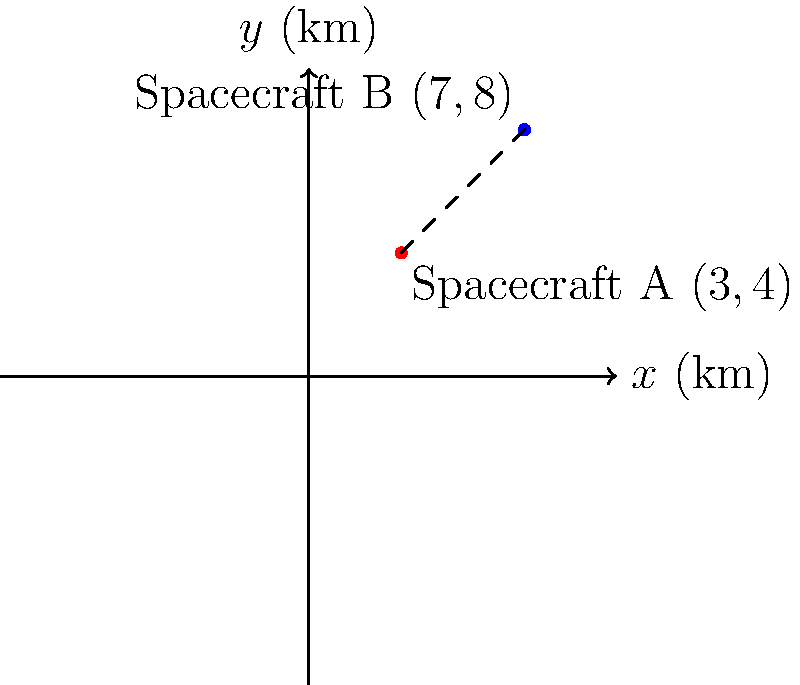Two spacecraft, A and B, are orbiting in the same plane around Earth. Their positions relative to a reference point are given in a coordinate system where each unit represents 1000 km. Spacecraft A is at coordinates (3, 4), and Spacecraft B is at (7, 8). Calculate the distance between the two spacecraft to the nearest kilometer. To calculate the distance between two points in a coordinate plane, we can use the distance formula, which is derived from the Pythagorean theorem:

$$d = \sqrt{(x_2 - x_1)^2 + (y_2 - y_1)^2}$$

Where $(x_1, y_1)$ are the coordinates of the first point and $(x_2, y_2)$ are the coordinates of the second point.

Let's solve this step by step:

1) Identify the coordinates:
   Spacecraft A: $(x_1, y_1) = (3, 4)$
   Spacecraft B: $(x_2, y_2) = (7, 8)$

2) Plug these values into the distance formula:
   $$d = \sqrt{(7 - 3)^2 + (8 - 4)^2}$$

3) Simplify inside the parentheses:
   $$d = \sqrt{4^2 + 4^2}$$

4) Calculate the squares:
   $$d = \sqrt{16 + 16}$$

5) Add inside the square root:
   $$d = \sqrt{32}$$

6) Simplify the square root:
   $$d = 4\sqrt{2}$$

7) Calculate the approximate value:
   $$d \approx 5.66$$

8) Remember that each unit represents 1000 km, so multiply by 1000:
   $$5.66 \times 1000 = 5660 \text{ km}$$

9) Round to the nearest kilometer:
   $$5660 \text{ km}$$

Therefore, the distance between the two spacecraft is approximately 5660 km.
Answer: 5660 km 